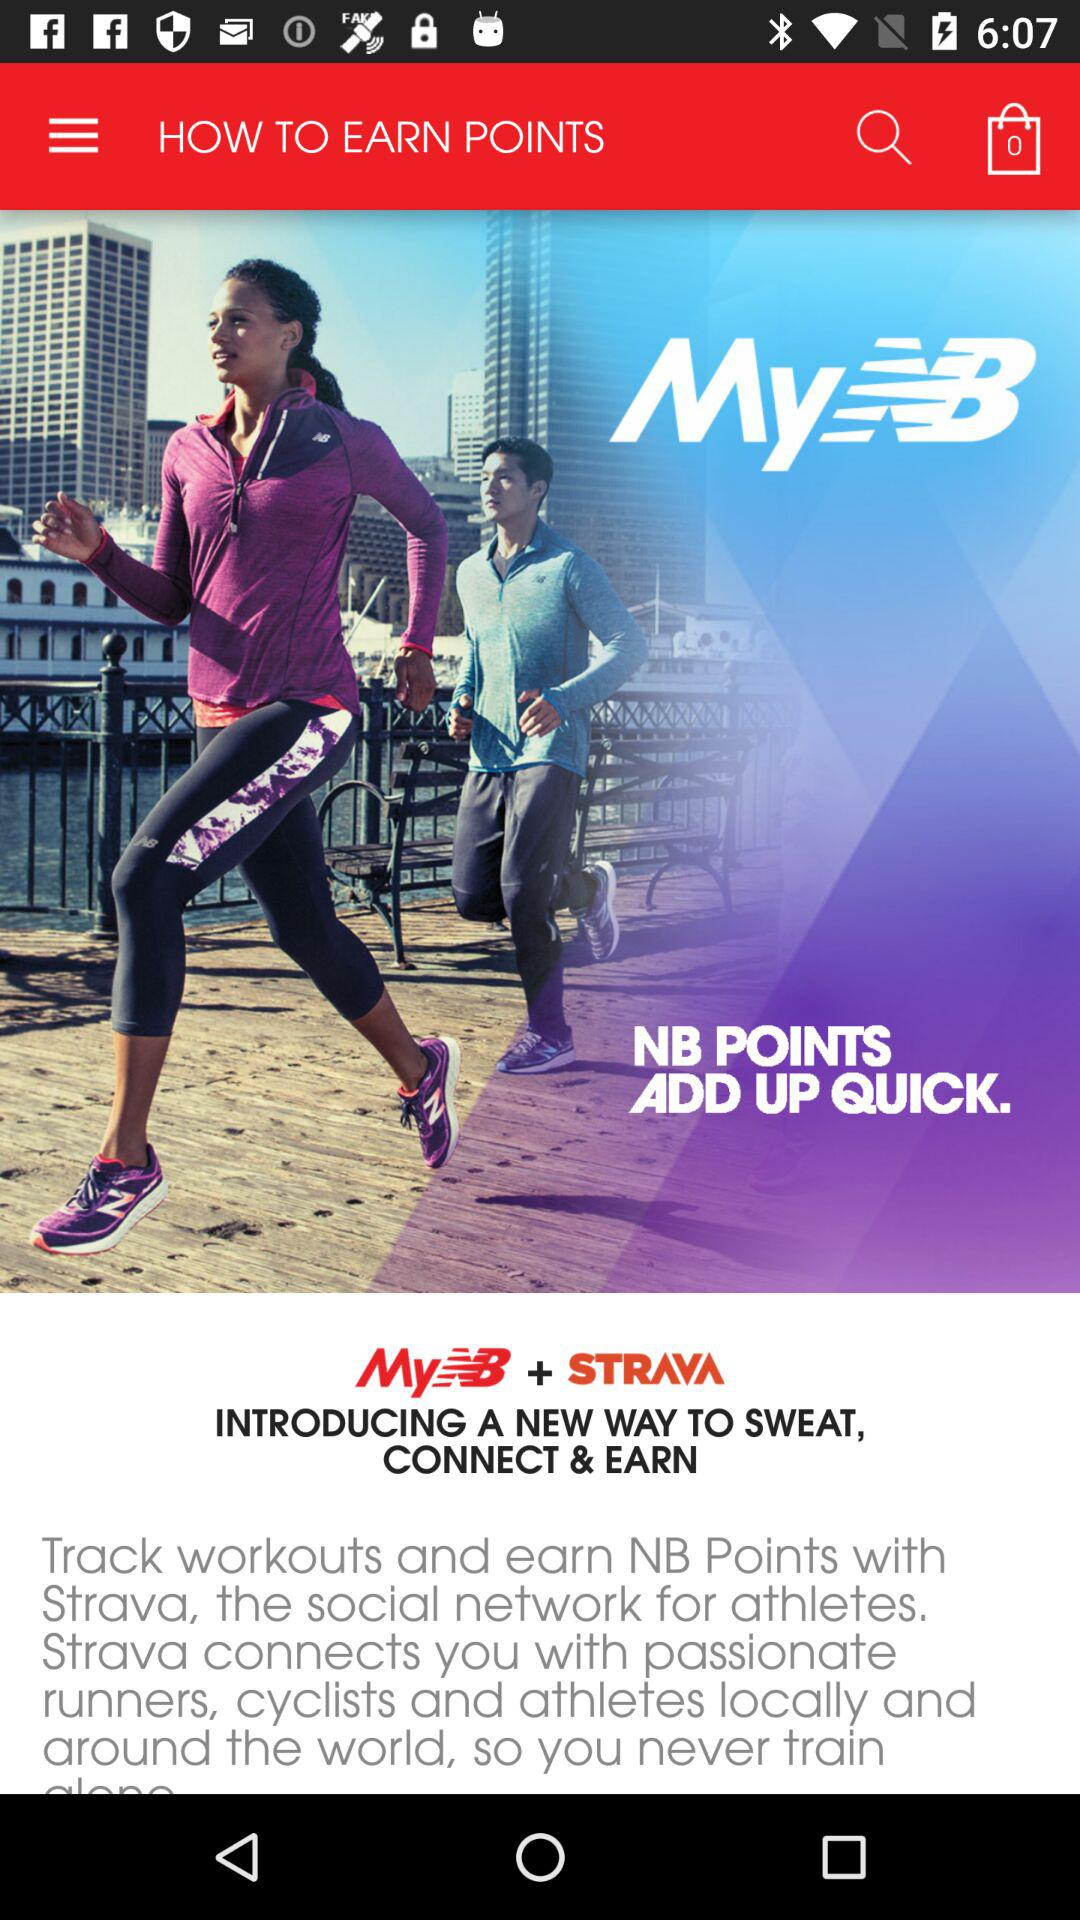How many people like "MyNB"?
When the provided information is insufficient, respond with <no answer>. <no answer> 